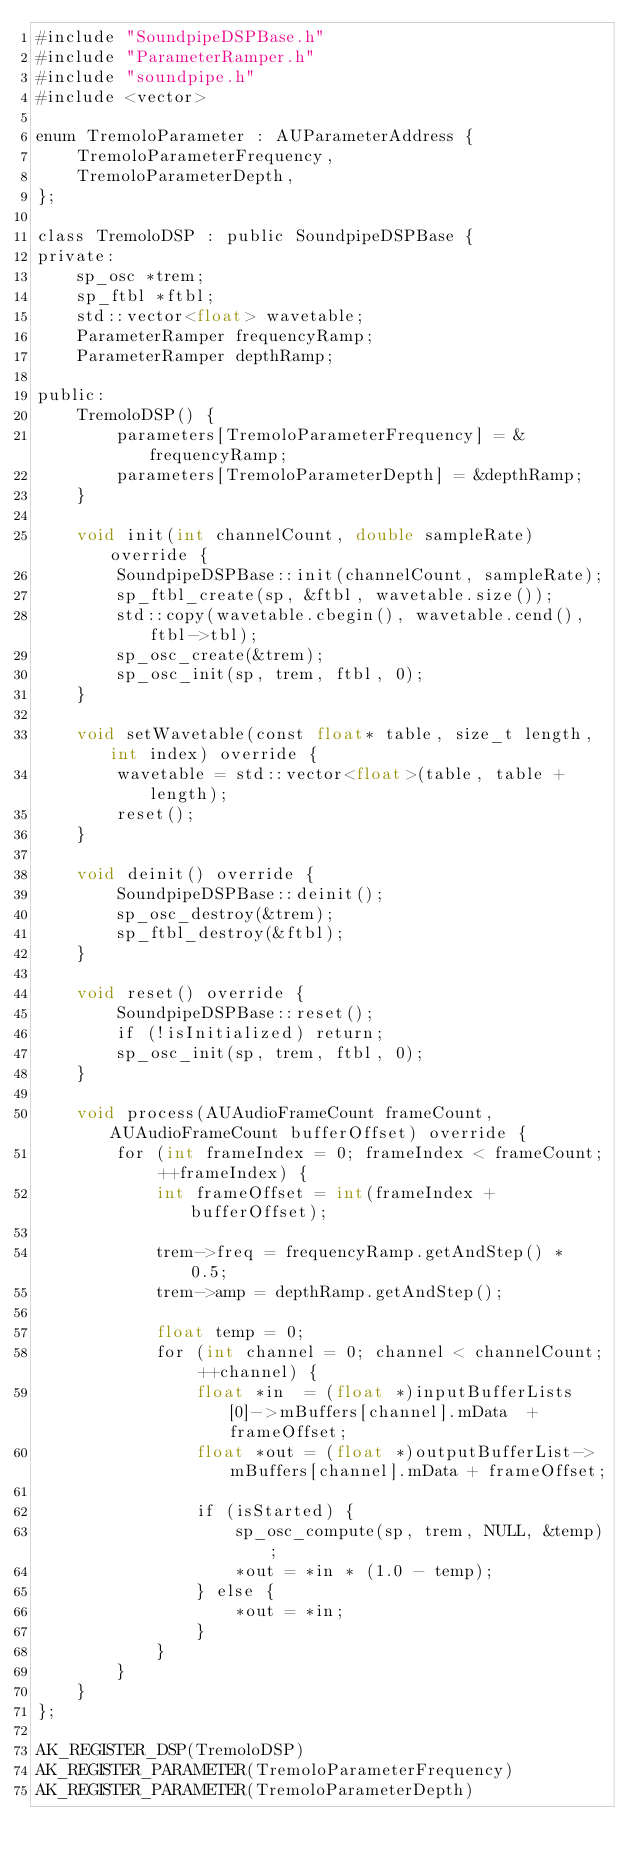Convert code to text. <code><loc_0><loc_0><loc_500><loc_500><_ObjectiveC_>#include "SoundpipeDSPBase.h"
#include "ParameterRamper.h"
#include "soundpipe.h"
#include <vector>

enum TremoloParameter : AUParameterAddress {
    TremoloParameterFrequency,
    TremoloParameterDepth,
};

class TremoloDSP : public SoundpipeDSPBase {
private:
    sp_osc *trem;
    sp_ftbl *ftbl;
    std::vector<float> wavetable;
    ParameterRamper frequencyRamp;
    ParameterRamper depthRamp;

public:
    TremoloDSP() {
        parameters[TremoloParameterFrequency] = &frequencyRamp;
        parameters[TremoloParameterDepth] = &depthRamp;
    }

    void init(int channelCount, double sampleRate) override {
        SoundpipeDSPBase::init(channelCount, sampleRate);
        sp_ftbl_create(sp, &ftbl, wavetable.size());
        std::copy(wavetable.cbegin(), wavetable.cend(), ftbl->tbl);
        sp_osc_create(&trem);
        sp_osc_init(sp, trem, ftbl, 0);
    }

    void setWavetable(const float* table, size_t length, int index) override {
        wavetable = std::vector<float>(table, table + length);
        reset();
    }

    void deinit() override {
        SoundpipeDSPBase::deinit();
        sp_osc_destroy(&trem);
        sp_ftbl_destroy(&ftbl);
    }

    void reset() override {
        SoundpipeDSPBase::reset();
        if (!isInitialized) return;
        sp_osc_init(sp, trem, ftbl, 0);
    }

    void process(AUAudioFrameCount frameCount, AUAudioFrameCount bufferOffset) override {
        for (int frameIndex = 0; frameIndex < frameCount; ++frameIndex) {
            int frameOffset = int(frameIndex + bufferOffset);

            trem->freq = frequencyRamp.getAndStep() * 0.5;
            trem->amp = depthRamp.getAndStep();

            float temp = 0;
            for (int channel = 0; channel < channelCount; ++channel) {
                float *in  = (float *)inputBufferLists[0]->mBuffers[channel].mData  + frameOffset;
                float *out = (float *)outputBufferList->mBuffers[channel].mData + frameOffset;

                if (isStarted) {
                    sp_osc_compute(sp, trem, NULL, &temp);
                    *out = *in * (1.0 - temp);
                } else {
                    *out = *in;
                }
            }
        }
    }
};

AK_REGISTER_DSP(TremoloDSP)
AK_REGISTER_PARAMETER(TremoloParameterFrequency)
AK_REGISTER_PARAMETER(TremoloParameterDepth)
</code> 